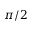Convert formula to latex. <formula><loc_0><loc_0><loc_500><loc_500>\pi / 2</formula> 